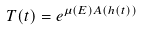<formula> <loc_0><loc_0><loc_500><loc_500>T ( t ) = e ^ { \mu ( E ) A ( h ( t ) ) }</formula> 